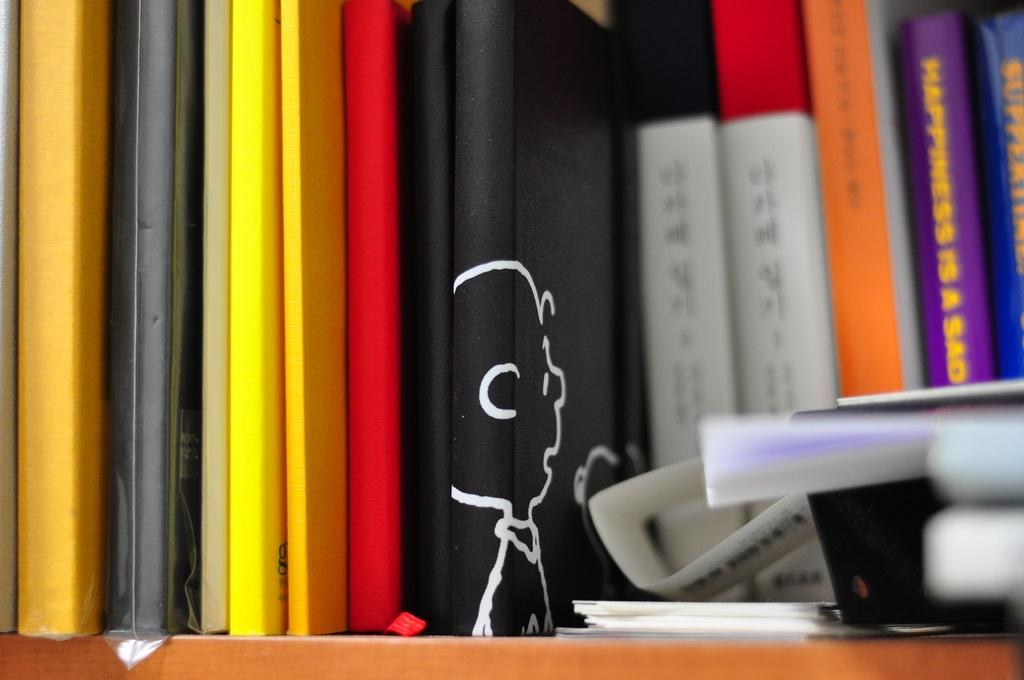<image>
Render a clear and concise summary of the photo. A bookshelf full of books, one book begins with Happiness is a sad. 